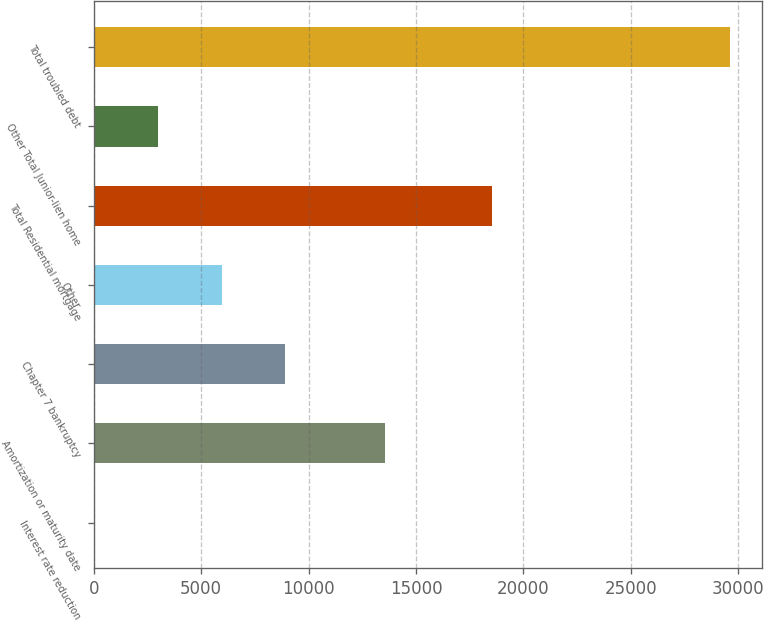Convert chart to OTSL. <chart><loc_0><loc_0><loc_500><loc_500><bar_chart><fcel>Interest rate reduction<fcel>Amortization or maturity date<fcel>Chapter 7 bankruptcy<fcel>Other<fcel>Total Residential mortgage<fcel>Other Total Junior-lien home<fcel>Total troubled debt<nl><fcel>61<fcel>13574<fcel>8927.8<fcel>5972.2<fcel>18524<fcel>3016.6<fcel>29617<nl></chart> 